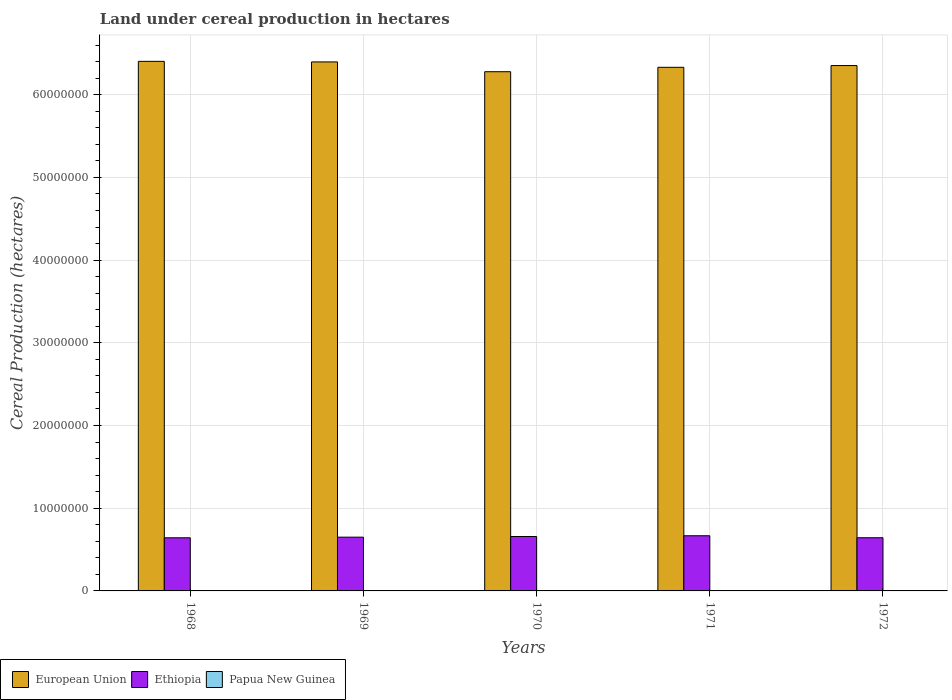How many different coloured bars are there?
Offer a terse response. 3. How many groups of bars are there?
Ensure brevity in your answer.  5. Are the number of bars on each tick of the X-axis equal?
Provide a short and direct response. Yes. How many bars are there on the 5th tick from the left?
Your answer should be compact. 3. How many bars are there on the 3rd tick from the right?
Offer a very short reply. 3. In how many cases, is the number of bars for a given year not equal to the number of legend labels?
Your answer should be very brief. 0. What is the land under cereal production in European Union in 1968?
Your answer should be compact. 6.40e+07. Across all years, what is the maximum land under cereal production in Ethiopia?
Your answer should be compact. 6.67e+06. Across all years, what is the minimum land under cereal production in European Union?
Keep it short and to the point. 6.28e+07. In which year was the land under cereal production in European Union maximum?
Your answer should be compact. 1968. In which year was the land under cereal production in Papua New Guinea minimum?
Your response must be concise. 1968. What is the total land under cereal production in European Union in the graph?
Make the answer very short. 3.18e+08. What is the difference between the land under cereal production in Papua New Guinea in 1968 and that in 1970?
Give a very brief answer. -488. What is the difference between the land under cereal production in European Union in 1972 and the land under cereal production in Ethiopia in 1971?
Offer a very short reply. 5.69e+07. What is the average land under cereal production in Papua New Guinea per year?
Give a very brief answer. 1411.2. In the year 1968, what is the difference between the land under cereal production in Ethiopia and land under cereal production in Papua New Guinea?
Give a very brief answer. 6.42e+06. In how many years, is the land under cereal production in Papua New Guinea greater than 24000000 hectares?
Your answer should be compact. 0. What is the ratio of the land under cereal production in Papua New Guinea in 1971 to that in 1972?
Your answer should be compact. 1.23. Is the land under cereal production in Ethiopia in 1969 less than that in 1970?
Your answer should be compact. Yes. What is the difference between the highest and the second highest land under cereal production in Ethiopia?
Your answer should be very brief. 9.01e+04. What is the difference between the highest and the lowest land under cereal production in Ethiopia?
Keep it short and to the point. 2.46e+05. In how many years, is the land under cereal production in Ethiopia greater than the average land under cereal production in Ethiopia taken over all years?
Your answer should be very brief. 2. Is the sum of the land under cereal production in Ethiopia in 1969 and 1970 greater than the maximum land under cereal production in European Union across all years?
Your answer should be compact. No. What does the 1st bar from the left in 1970 represents?
Ensure brevity in your answer.  European Union. What does the 1st bar from the right in 1971 represents?
Provide a short and direct response. Papua New Guinea. How many years are there in the graph?
Offer a terse response. 5. What is the difference between two consecutive major ticks on the Y-axis?
Ensure brevity in your answer.  1.00e+07. Where does the legend appear in the graph?
Your answer should be very brief. Bottom left. How many legend labels are there?
Ensure brevity in your answer.  3. How are the legend labels stacked?
Keep it short and to the point. Horizontal. What is the title of the graph?
Offer a terse response. Land under cereal production in hectares. Does "Bahrain" appear as one of the legend labels in the graph?
Give a very brief answer. No. What is the label or title of the X-axis?
Your answer should be compact. Years. What is the label or title of the Y-axis?
Provide a succinct answer. Cereal Production (hectares). What is the Cereal Production (hectares) in European Union in 1968?
Your answer should be compact. 6.40e+07. What is the Cereal Production (hectares) in Ethiopia in 1968?
Your response must be concise. 6.42e+06. What is the Cereal Production (hectares) in Papua New Guinea in 1968?
Make the answer very short. 987. What is the Cereal Production (hectares) of European Union in 1969?
Ensure brevity in your answer.  6.40e+07. What is the Cereal Production (hectares) of Ethiopia in 1969?
Give a very brief answer. 6.50e+06. What is the Cereal Production (hectares) in Papua New Guinea in 1969?
Ensure brevity in your answer.  1349. What is the Cereal Production (hectares) of European Union in 1970?
Make the answer very short. 6.28e+07. What is the Cereal Production (hectares) in Ethiopia in 1970?
Keep it short and to the point. 6.58e+06. What is the Cereal Production (hectares) of Papua New Guinea in 1970?
Offer a very short reply. 1475. What is the Cereal Production (hectares) of European Union in 1971?
Ensure brevity in your answer.  6.33e+07. What is the Cereal Production (hectares) of Ethiopia in 1971?
Offer a terse response. 6.67e+06. What is the Cereal Production (hectares) in Papua New Guinea in 1971?
Offer a terse response. 1791. What is the Cereal Production (hectares) in European Union in 1972?
Give a very brief answer. 6.35e+07. What is the Cereal Production (hectares) of Ethiopia in 1972?
Keep it short and to the point. 6.43e+06. What is the Cereal Production (hectares) of Papua New Guinea in 1972?
Provide a succinct answer. 1454. Across all years, what is the maximum Cereal Production (hectares) in European Union?
Your response must be concise. 6.40e+07. Across all years, what is the maximum Cereal Production (hectares) of Ethiopia?
Your response must be concise. 6.67e+06. Across all years, what is the maximum Cereal Production (hectares) in Papua New Guinea?
Offer a very short reply. 1791. Across all years, what is the minimum Cereal Production (hectares) in European Union?
Provide a short and direct response. 6.28e+07. Across all years, what is the minimum Cereal Production (hectares) of Ethiopia?
Offer a terse response. 6.42e+06. Across all years, what is the minimum Cereal Production (hectares) in Papua New Guinea?
Give a very brief answer. 987. What is the total Cereal Production (hectares) in European Union in the graph?
Offer a very short reply. 3.18e+08. What is the total Cereal Production (hectares) of Ethiopia in the graph?
Provide a succinct answer. 3.26e+07. What is the total Cereal Production (hectares) in Papua New Guinea in the graph?
Ensure brevity in your answer.  7056. What is the difference between the Cereal Production (hectares) in European Union in 1968 and that in 1969?
Give a very brief answer. 6.81e+04. What is the difference between the Cereal Production (hectares) in Ethiopia in 1968 and that in 1969?
Keep it short and to the point. -7.55e+04. What is the difference between the Cereal Production (hectares) of Papua New Guinea in 1968 and that in 1969?
Your answer should be very brief. -362. What is the difference between the Cereal Production (hectares) in European Union in 1968 and that in 1970?
Offer a terse response. 1.25e+06. What is the difference between the Cereal Production (hectares) in Ethiopia in 1968 and that in 1970?
Your answer should be very brief. -1.56e+05. What is the difference between the Cereal Production (hectares) of Papua New Guinea in 1968 and that in 1970?
Your answer should be very brief. -488. What is the difference between the Cereal Production (hectares) in European Union in 1968 and that in 1971?
Ensure brevity in your answer.  7.20e+05. What is the difference between the Cereal Production (hectares) in Ethiopia in 1968 and that in 1971?
Your answer should be compact. -2.46e+05. What is the difference between the Cereal Production (hectares) of Papua New Guinea in 1968 and that in 1971?
Keep it short and to the point. -804. What is the difference between the Cereal Production (hectares) of European Union in 1968 and that in 1972?
Make the answer very short. 5.08e+05. What is the difference between the Cereal Production (hectares) in Ethiopia in 1968 and that in 1972?
Keep it short and to the point. -5200. What is the difference between the Cereal Production (hectares) in Papua New Guinea in 1968 and that in 1972?
Ensure brevity in your answer.  -467. What is the difference between the Cereal Production (hectares) in European Union in 1969 and that in 1970?
Your answer should be very brief. 1.18e+06. What is the difference between the Cereal Production (hectares) in Ethiopia in 1969 and that in 1970?
Give a very brief answer. -8.04e+04. What is the difference between the Cereal Production (hectares) of Papua New Guinea in 1969 and that in 1970?
Provide a succinct answer. -126. What is the difference between the Cereal Production (hectares) in European Union in 1969 and that in 1971?
Your answer should be very brief. 6.52e+05. What is the difference between the Cereal Production (hectares) of Ethiopia in 1969 and that in 1971?
Provide a succinct answer. -1.70e+05. What is the difference between the Cereal Production (hectares) in Papua New Guinea in 1969 and that in 1971?
Offer a terse response. -442. What is the difference between the Cereal Production (hectares) in European Union in 1969 and that in 1972?
Your response must be concise. 4.40e+05. What is the difference between the Cereal Production (hectares) in Ethiopia in 1969 and that in 1972?
Your answer should be very brief. 7.03e+04. What is the difference between the Cereal Production (hectares) of Papua New Guinea in 1969 and that in 1972?
Your answer should be compact. -105. What is the difference between the Cereal Production (hectares) of European Union in 1970 and that in 1971?
Ensure brevity in your answer.  -5.33e+05. What is the difference between the Cereal Production (hectares) in Ethiopia in 1970 and that in 1971?
Provide a succinct answer. -9.01e+04. What is the difference between the Cereal Production (hectares) of Papua New Guinea in 1970 and that in 1971?
Ensure brevity in your answer.  -316. What is the difference between the Cereal Production (hectares) of European Union in 1970 and that in 1972?
Offer a terse response. -7.44e+05. What is the difference between the Cereal Production (hectares) of Ethiopia in 1970 and that in 1972?
Give a very brief answer. 1.51e+05. What is the difference between the Cereal Production (hectares) of European Union in 1971 and that in 1972?
Give a very brief answer. -2.12e+05. What is the difference between the Cereal Production (hectares) in Ethiopia in 1971 and that in 1972?
Your answer should be compact. 2.41e+05. What is the difference between the Cereal Production (hectares) in Papua New Guinea in 1971 and that in 1972?
Your response must be concise. 337. What is the difference between the Cereal Production (hectares) in European Union in 1968 and the Cereal Production (hectares) in Ethiopia in 1969?
Offer a terse response. 5.75e+07. What is the difference between the Cereal Production (hectares) in European Union in 1968 and the Cereal Production (hectares) in Papua New Guinea in 1969?
Make the answer very short. 6.40e+07. What is the difference between the Cereal Production (hectares) of Ethiopia in 1968 and the Cereal Production (hectares) of Papua New Guinea in 1969?
Your response must be concise. 6.42e+06. What is the difference between the Cereal Production (hectares) in European Union in 1968 and the Cereal Production (hectares) in Ethiopia in 1970?
Your answer should be compact. 5.75e+07. What is the difference between the Cereal Production (hectares) of European Union in 1968 and the Cereal Production (hectares) of Papua New Guinea in 1970?
Provide a succinct answer. 6.40e+07. What is the difference between the Cereal Production (hectares) in Ethiopia in 1968 and the Cereal Production (hectares) in Papua New Guinea in 1970?
Make the answer very short. 6.42e+06. What is the difference between the Cereal Production (hectares) in European Union in 1968 and the Cereal Production (hectares) in Ethiopia in 1971?
Make the answer very short. 5.74e+07. What is the difference between the Cereal Production (hectares) in European Union in 1968 and the Cereal Production (hectares) in Papua New Guinea in 1971?
Your answer should be very brief. 6.40e+07. What is the difference between the Cereal Production (hectares) of Ethiopia in 1968 and the Cereal Production (hectares) of Papua New Guinea in 1971?
Make the answer very short. 6.42e+06. What is the difference between the Cereal Production (hectares) of European Union in 1968 and the Cereal Production (hectares) of Ethiopia in 1972?
Keep it short and to the point. 5.76e+07. What is the difference between the Cereal Production (hectares) in European Union in 1968 and the Cereal Production (hectares) in Papua New Guinea in 1972?
Your answer should be very brief. 6.40e+07. What is the difference between the Cereal Production (hectares) in Ethiopia in 1968 and the Cereal Production (hectares) in Papua New Guinea in 1972?
Your answer should be very brief. 6.42e+06. What is the difference between the Cereal Production (hectares) of European Union in 1969 and the Cereal Production (hectares) of Ethiopia in 1970?
Make the answer very short. 5.74e+07. What is the difference between the Cereal Production (hectares) in European Union in 1969 and the Cereal Production (hectares) in Papua New Guinea in 1970?
Provide a short and direct response. 6.40e+07. What is the difference between the Cereal Production (hectares) in Ethiopia in 1969 and the Cereal Production (hectares) in Papua New Guinea in 1970?
Make the answer very short. 6.50e+06. What is the difference between the Cereal Production (hectares) in European Union in 1969 and the Cereal Production (hectares) in Ethiopia in 1971?
Your response must be concise. 5.73e+07. What is the difference between the Cereal Production (hectares) in European Union in 1969 and the Cereal Production (hectares) in Papua New Guinea in 1971?
Your response must be concise. 6.40e+07. What is the difference between the Cereal Production (hectares) in Ethiopia in 1969 and the Cereal Production (hectares) in Papua New Guinea in 1971?
Your answer should be very brief. 6.50e+06. What is the difference between the Cereal Production (hectares) of European Union in 1969 and the Cereal Production (hectares) of Ethiopia in 1972?
Your response must be concise. 5.75e+07. What is the difference between the Cereal Production (hectares) of European Union in 1969 and the Cereal Production (hectares) of Papua New Guinea in 1972?
Provide a succinct answer. 6.40e+07. What is the difference between the Cereal Production (hectares) in Ethiopia in 1969 and the Cereal Production (hectares) in Papua New Guinea in 1972?
Provide a succinct answer. 6.50e+06. What is the difference between the Cereal Production (hectares) in European Union in 1970 and the Cereal Production (hectares) in Ethiopia in 1971?
Keep it short and to the point. 5.61e+07. What is the difference between the Cereal Production (hectares) of European Union in 1970 and the Cereal Production (hectares) of Papua New Guinea in 1971?
Give a very brief answer. 6.28e+07. What is the difference between the Cereal Production (hectares) of Ethiopia in 1970 and the Cereal Production (hectares) of Papua New Guinea in 1971?
Ensure brevity in your answer.  6.58e+06. What is the difference between the Cereal Production (hectares) of European Union in 1970 and the Cereal Production (hectares) of Ethiopia in 1972?
Offer a terse response. 5.63e+07. What is the difference between the Cereal Production (hectares) of European Union in 1970 and the Cereal Production (hectares) of Papua New Guinea in 1972?
Keep it short and to the point. 6.28e+07. What is the difference between the Cereal Production (hectares) of Ethiopia in 1970 and the Cereal Production (hectares) of Papua New Guinea in 1972?
Your response must be concise. 6.58e+06. What is the difference between the Cereal Production (hectares) in European Union in 1971 and the Cereal Production (hectares) in Ethiopia in 1972?
Offer a terse response. 5.69e+07. What is the difference between the Cereal Production (hectares) of European Union in 1971 and the Cereal Production (hectares) of Papua New Guinea in 1972?
Ensure brevity in your answer.  6.33e+07. What is the difference between the Cereal Production (hectares) in Ethiopia in 1971 and the Cereal Production (hectares) in Papua New Guinea in 1972?
Provide a succinct answer. 6.67e+06. What is the average Cereal Production (hectares) in European Union per year?
Give a very brief answer. 6.35e+07. What is the average Cereal Production (hectares) of Ethiopia per year?
Keep it short and to the point. 6.52e+06. What is the average Cereal Production (hectares) in Papua New Guinea per year?
Your answer should be very brief. 1411.2. In the year 1968, what is the difference between the Cereal Production (hectares) in European Union and Cereal Production (hectares) in Ethiopia?
Ensure brevity in your answer.  5.76e+07. In the year 1968, what is the difference between the Cereal Production (hectares) of European Union and Cereal Production (hectares) of Papua New Guinea?
Keep it short and to the point. 6.40e+07. In the year 1968, what is the difference between the Cereal Production (hectares) in Ethiopia and Cereal Production (hectares) in Papua New Guinea?
Offer a very short reply. 6.42e+06. In the year 1969, what is the difference between the Cereal Production (hectares) in European Union and Cereal Production (hectares) in Ethiopia?
Give a very brief answer. 5.75e+07. In the year 1969, what is the difference between the Cereal Production (hectares) in European Union and Cereal Production (hectares) in Papua New Guinea?
Give a very brief answer. 6.40e+07. In the year 1969, what is the difference between the Cereal Production (hectares) in Ethiopia and Cereal Production (hectares) in Papua New Guinea?
Keep it short and to the point. 6.50e+06. In the year 1970, what is the difference between the Cereal Production (hectares) of European Union and Cereal Production (hectares) of Ethiopia?
Offer a terse response. 5.62e+07. In the year 1970, what is the difference between the Cereal Production (hectares) in European Union and Cereal Production (hectares) in Papua New Guinea?
Your answer should be compact. 6.28e+07. In the year 1970, what is the difference between the Cereal Production (hectares) of Ethiopia and Cereal Production (hectares) of Papua New Guinea?
Offer a terse response. 6.58e+06. In the year 1971, what is the difference between the Cereal Production (hectares) in European Union and Cereal Production (hectares) in Ethiopia?
Provide a short and direct response. 5.66e+07. In the year 1971, what is the difference between the Cereal Production (hectares) of European Union and Cereal Production (hectares) of Papua New Guinea?
Your response must be concise. 6.33e+07. In the year 1971, what is the difference between the Cereal Production (hectares) of Ethiopia and Cereal Production (hectares) of Papua New Guinea?
Offer a terse response. 6.67e+06. In the year 1972, what is the difference between the Cereal Production (hectares) of European Union and Cereal Production (hectares) of Ethiopia?
Your answer should be very brief. 5.71e+07. In the year 1972, what is the difference between the Cereal Production (hectares) of European Union and Cereal Production (hectares) of Papua New Guinea?
Make the answer very short. 6.35e+07. In the year 1972, what is the difference between the Cereal Production (hectares) in Ethiopia and Cereal Production (hectares) in Papua New Guinea?
Provide a short and direct response. 6.43e+06. What is the ratio of the Cereal Production (hectares) of European Union in 1968 to that in 1969?
Your answer should be very brief. 1. What is the ratio of the Cereal Production (hectares) of Ethiopia in 1968 to that in 1969?
Your answer should be compact. 0.99. What is the ratio of the Cereal Production (hectares) of Papua New Guinea in 1968 to that in 1969?
Give a very brief answer. 0.73. What is the ratio of the Cereal Production (hectares) of European Union in 1968 to that in 1970?
Make the answer very short. 1.02. What is the ratio of the Cereal Production (hectares) of Ethiopia in 1968 to that in 1970?
Offer a very short reply. 0.98. What is the ratio of the Cereal Production (hectares) in Papua New Guinea in 1968 to that in 1970?
Make the answer very short. 0.67. What is the ratio of the Cereal Production (hectares) in European Union in 1968 to that in 1971?
Provide a short and direct response. 1.01. What is the ratio of the Cereal Production (hectares) in Ethiopia in 1968 to that in 1971?
Make the answer very short. 0.96. What is the ratio of the Cereal Production (hectares) in Papua New Guinea in 1968 to that in 1971?
Your answer should be compact. 0.55. What is the ratio of the Cereal Production (hectares) in European Union in 1968 to that in 1972?
Provide a succinct answer. 1.01. What is the ratio of the Cereal Production (hectares) in Ethiopia in 1968 to that in 1972?
Offer a very short reply. 1. What is the ratio of the Cereal Production (hectares) of Papua New Guinea in 1968 to that in 1972?
Your answer should be compact. 0.68. What is the ratio of the Cereal Production (hectares) of European Union in 1969 to that in 1970?
Provide a succinct answer. 1.02. What is the ratio of the Cereal Production (hectares) in Papua New Guinea in 1969 to that in 1970?
Your answer should be very brief. 0.91. What is the ratio of the Cereal Production (hectares) in European Union in 1969 to that in 1971?
Provide a succinct answer. 1.01. What is the ratio of the Cereal Production (hectares) in Ethiopia in 1969 to that in 1971?
Give a very brief answer. 0.97. What is the ratio of the Cereal Production (hectares) of Papua New Guinea in 1969 to that in 1971?
Provide a succinct answer. 0.75. What is the ratio of the Cereal Production (hectares) in European Union in 1969 to that in 1972?
Offer a terse response. 1.01. What is the ratio of the Cereal Production (hectares) in Ethiopia in 1969 to that in 1972?
Make the answer very short. 1.01. What is the ratio of the Cereal Production (hectares) in Papua New Guinea in 1969 to that in 1972?
Keep it short and to the point. 0.93. What is the ratio of the Cereal Production (hectares) of European Union in 1970 to that in 1971?
Give a very brief answer. 0.99. What is the ratio of the Cereal Production (hectares) of Ethiopia in 1970 to that in 1971?
Provide a short and direct response. 0.99. What is the ratio of the Cereal Production (hectares) in Papua New Guinea in 1970 to that in 1971?
Your response must be concise. 0.82. What is the ratio of the Cereal Production (hectares) of European Union in 1970 to that in 1972?
Provide a short and direct response. 0.99. What is the ratio of the Cereal Production (hectares) in Ethiopia in 1970 to that in 1972?
Provide a short and direct response. 1.02. What is the ratio of the Cereal Production (hectares) in Papua New Guinea in 1970 to that in 1972?
Your answer should be very brief. 1.01. What is the ratio of the Cereal Production (hectares) in European Union in 1971 to that in 1972?
Provide a succinct answer. 1. What is the ratio of the Cereal Production (hectares) of Ethiopia in 1971 to that in 1972?
Make the answer very short. 1.04. What is the ratio of the Cereal Production (hectares) in Papua New Guinea in 1971 to that in 1972?
Your answer should be compact. 1.23. What is the difference between the highest and the second highest Cereal Production (hectares) in European Union?
Offer a terse response. 6.81e+04. What is the difference between the highest and the second highest Cereal Production (hectares) in Ethiopia?
Give a very brief answer. 9.01e+04. What is the difference between the highest and the second highest Cereal Production (hectares) of Papua New Guinea?
Your answer should be very brief. 316. What is the difference between the highest and the lowest Cereal Production (hectares) in European Union?
Give a very brief answer. 1.25e+06. What is the difference between the highest and the lowest Cereal Production (hectares) in Ethiopia?
Make the answer very short. 2.46e+05. What is the difference between the highest and the lowest Cereal Production (hectares) of Papua New Guinea?
Keep it short and to the point. 804. 